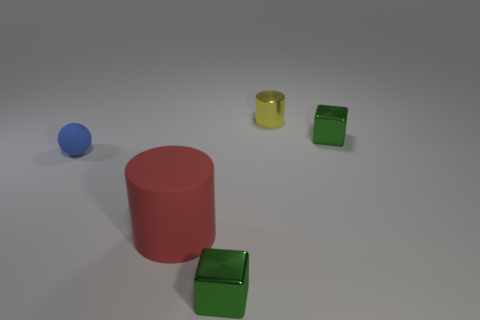There is a small cube behind the green metallic cube left of the cube that is behind the blue rubber thing; what color is it?
Offer a very short reply. Green. Do the cylinder to the right of the big object and the small green cube that is behind the rubber ball have the same material?
Your answer should be very brief. Yes. How many things are either tiny green shiny things in front of the blue object or gray blocks?
Give a very brief answer. 1. How many things are metal objects or small rubber spheres that are in front of the yellow metal object?
Offer a terse response. 4. How many things have the same size as the rubber sphere?
Keep it short and to the point. 3. Is the number of yellow metal objects right of the tiny yellow cylinder less than the number of big rubber cylinders that are on the left side of the red cylinder?
Provide a short and direct response. No. What number of shiny objects are small green things or big objects?
Provide a short and direct response. 2. What is the shape of the big red object?
Give a very brief answer. Cylinder. What is the material of the blue ball that is the same size as the yellow thing?
Your answer should be very brief. Rubber. What number of small things are either metallic blocks or blue rubber spheres?
Provide a short and direct response. 3. 